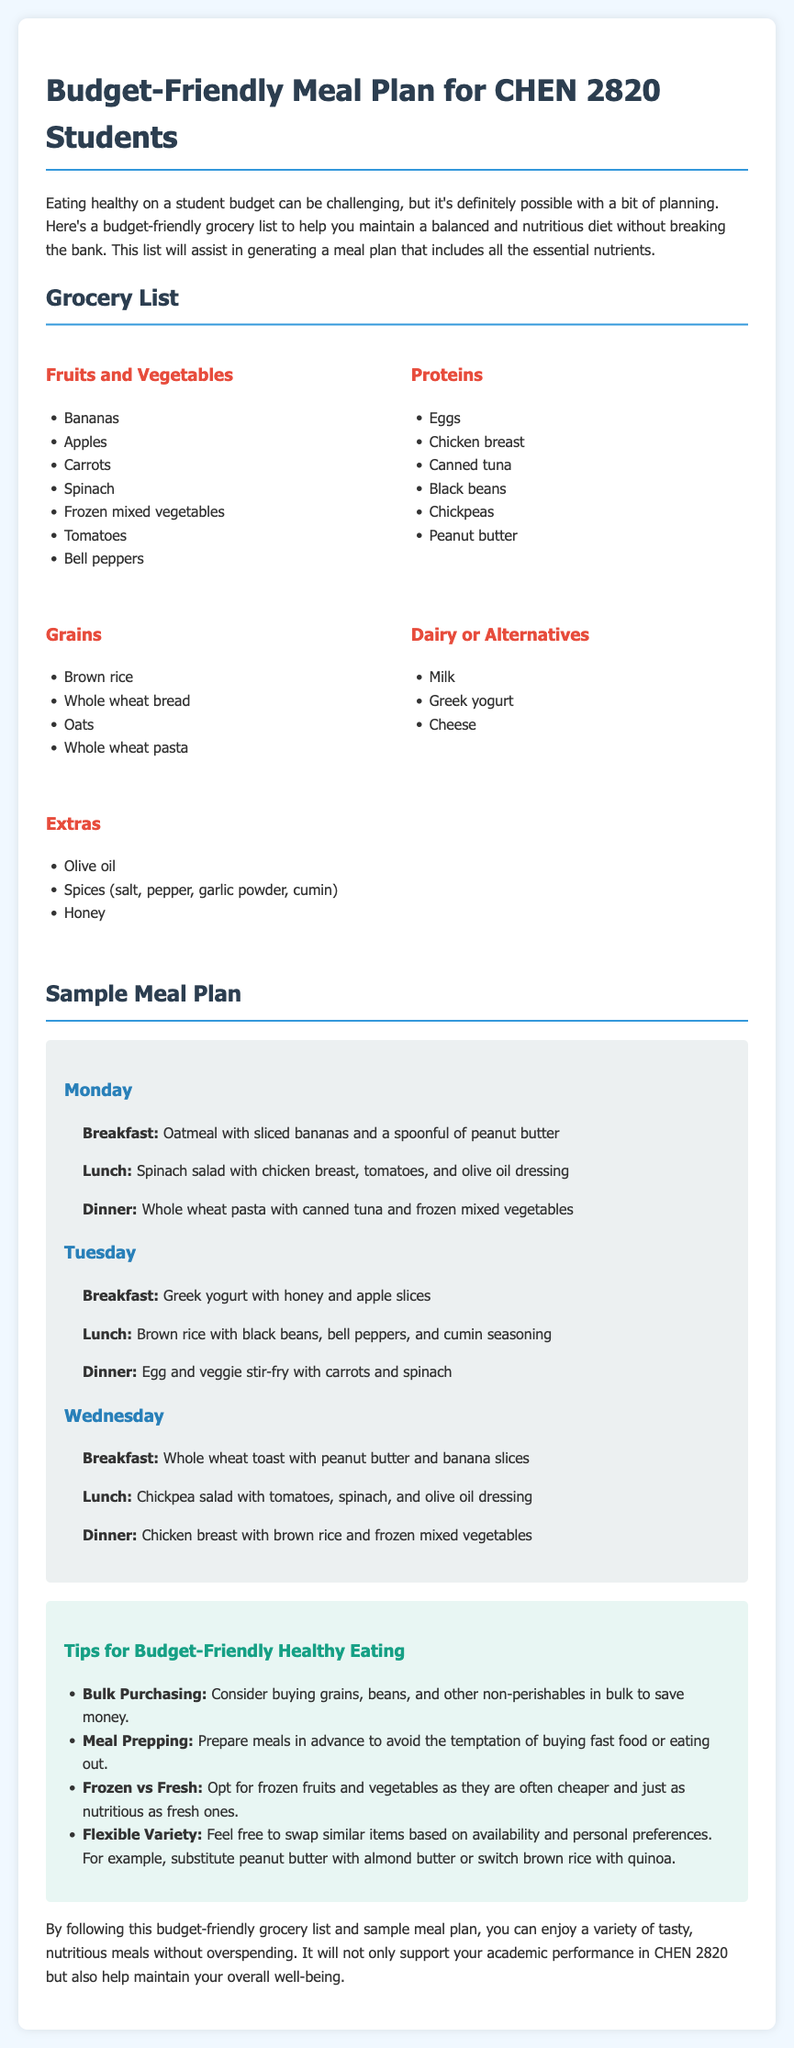What is the main theme of the document? The document focuses on providing a budget-friendly meal plan for students, emphasizing healthy eating on a budget.
Answer: Budget-friendly meal plan for students How many types of grocery categories are listed? The document has five categories of groceries: Fruits and Vegetables, Proteins, Grains, Dairy or Alternatives, and Extras.
Answer: Five What is the first item in the Fruits and Vegetables category? The first item listed under Fruits and Vegetables is Bananas.
Answer: Bananas What is suggested for breakfast on Tuesday? The document specifies Greek yogurt with honey and apple slices for Tuesday’s breakfast.
Answer: Greek yogurt with honey and apple slices What protein source is suggested for lunch on Monday? For lunch on Monday, the suggested protein source is chicken breast.
Answer: Chicken breast Which meal includes canned tuna? Canned tuna is included in Monday's dinner.
Answer: Monday's dinner How many meals are listed for each day in the sample meal plan? Three meals (breakfast, lunch, and dinner) are listed for each day in the sample meal plan.
Answer: Three What is a recommended tip for healthy eating? One tip suggests: "Consider buying grains, beans, and other non-perishables in bulk to save money."
Answer: Buy in bulk Which grocery list category includes honey? Honey is listed under the Extras category of the grocery list.
Answer: Extras 